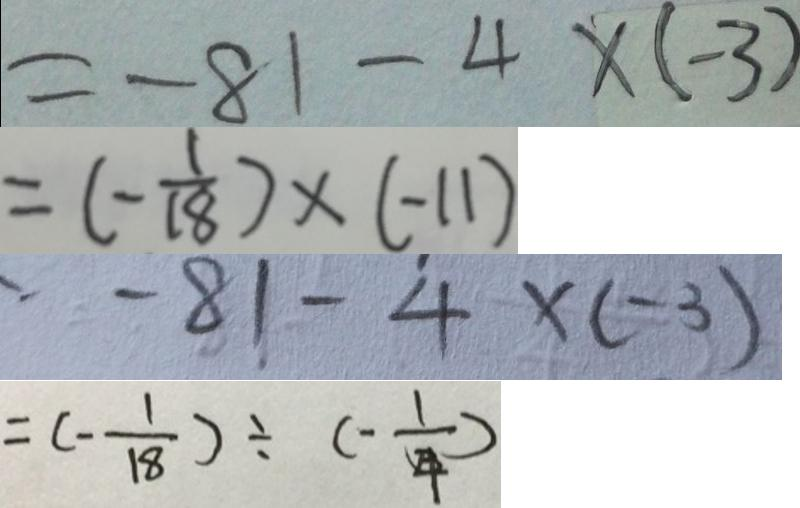Convert formula to latex. <formula><loc_0><loc_0><loc_500><loc_500>= - 8 1 - 4 \times ( - 3 ) 
 = ( - \frac { 1 } { 1 8 } ) \times ( - 1 1 ) 
 - 8 1 - 4 \times ( - 3 ) 
 = ( - \frac { 1 } { 1 8 } ) \div ( - \frac { 1 } { 4 } )</formula> 